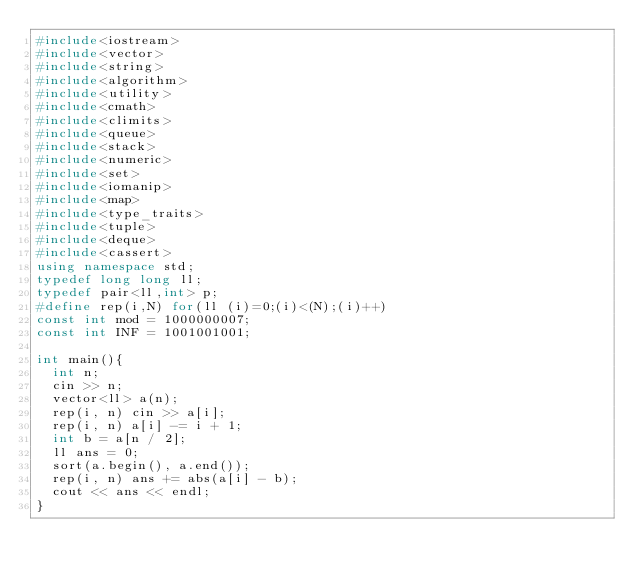Convert code to text. <code><loc_0><loc_0><loc_500><loc_500><_C++_>#include<iostream>
#include<vector>
#include<string>
#include<algorithm>
#include<utility>
#include<cmath>
#include<climits>
#include<queue>
#include<stack>
#include<numeric>
#include<set>
#include<iomanip>
#include<map>
#include<type_traits>
#include<tuple>
#include<deque>
#include<cassert>
using namespace std;
typedef long long ll;
typedef pair<ll,int> p;
#define rep(i,N) for(ll (i)=0;(i)<(N);(i)++)
const int mod = 1000000007;
const int INF = 1001001001;

int main(){
  int n;
  cin >> n;
  vector<ll> a(n);
  rep(i, n) cin >> a[i];
  rep(i, n) a[i] -= i + 1;
  int b = a[n / 2];
  ll ans = 0;
  sort(a.begin(), a.end());
  rep(i, n) ans += abs(a[i] - b);
  cout << ans << endl;
}
</code> 